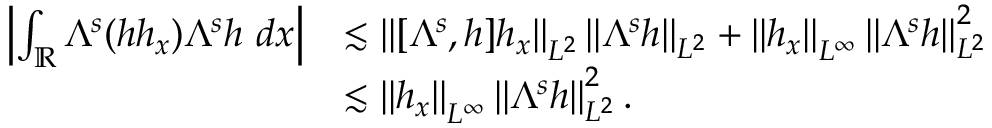<formula> <loc_0><loc_0><loc_500><loc_500>\begin{array} { r l } { \left | \int _ { \mathbb { R } } \Lambda ^ { s } ( h h _ { x } ) \Lambda ^ { s } h \ d x \right | } & { \lesssim \left \| [ \Lambda ^ { s } , h ] h _ { x } \right \| _ { L ^ { 2 } } \left \| \Lambda ^ { s } h \right \| _ { L ^ { 2 } } + \left \| h _ { x } \right \| _ { L ^ { \infty } } \left \| \Lambda ^ { s } h \right \| _ { L ^ { 2 } } ^ { 2 } } \\ & { \lesssim \left \| h _ { x } \right \| _ { L ^ { \infty } } \left \| \Lambda ^ { s } h \right \| _ { L ^ { 2 } } ^ { 2 } . } \end{array}</formula> 